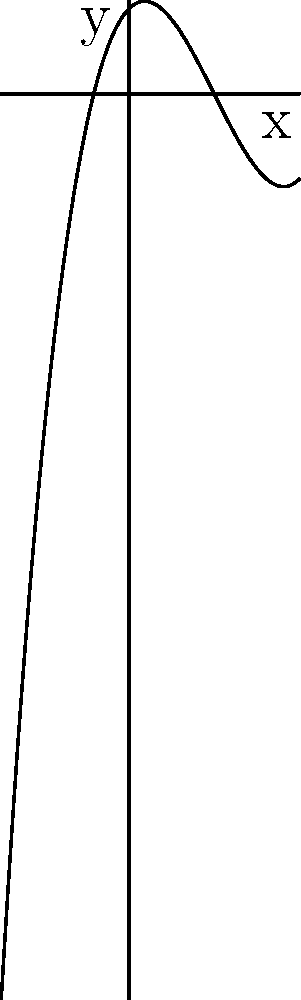As an aspiring writer looking to diversify your income, you've been asked to proofread a math textbook. You come across a polynomial graph and need to determine its degree and leading coefficient. Based on the graph shown, what is the degree of the polynomial and its leading coefficient? To determine the degree and leading coefficient of a polynomial from its graph, we need to follow these steps:

1. Observe the end behavior of the graph:
   - As x approaches positive infinity, y approaches positive infinity.
   - As x approaches negative infinity, y approaches negative infinity.
   This behavior is characteristic of an odd-degree polynomial with a positive leading coefficient.

2. Count the number of turning points:
   - The graph has two turning points.
   - The maximum number of turning points for a polynomial of degree n is (n-1).
   - So, the degree must be at least 3 to accommodate these two turning points.

3. Determine the degree:
   - Given the end behavior and the number of turning points, we can conclude that the degree is 3.

4. Estimate the leading coefficient:
   - For a cubic function $f(x) = ax^3 + bx^2 + cx + d$, the leading coefficient 'a' determines how steep the graph is for large values of x.
   - The graph doesn't appear very steep, suggesting a small positive value for 'a'.
   - A reasonable estimate for the leading coefficient would be 0.25.

Therefore, the polynomial is likely of the form $f(x) = 0.25x^3 + bx^2 + cx + d$.
Answer: Degree: 3, Leading coefficient: 0.25 